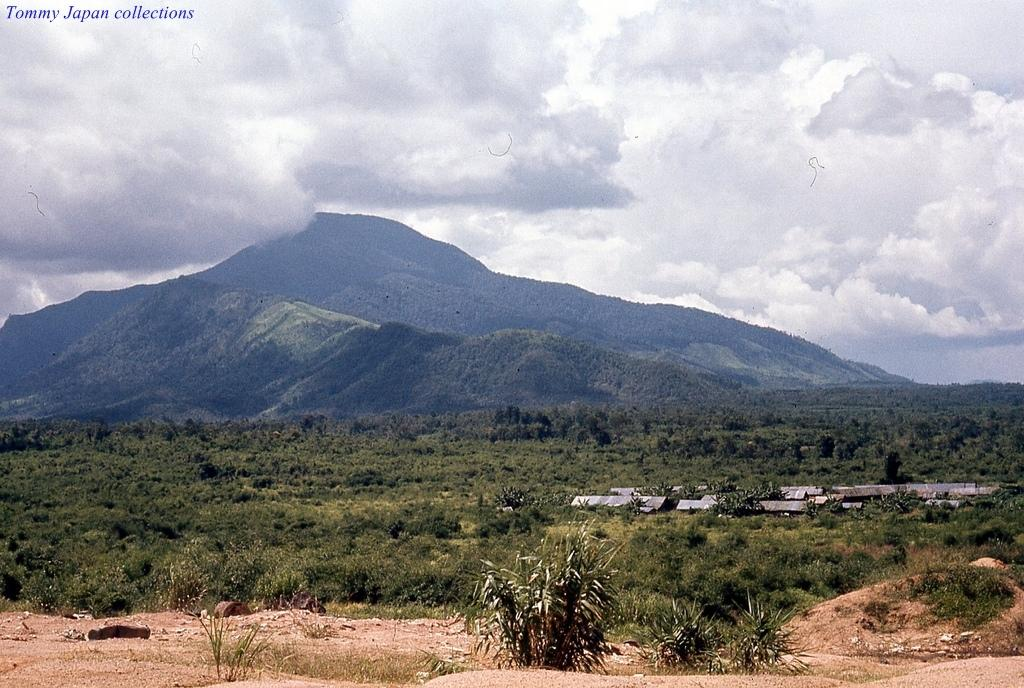What can be found at the bottom of the image? There are plants, trees, pipes, and land at the bottom of the image. What is visible at the top of the image? There are hills, sky, clouds, and text at the top of the image. What type of vegetation is present at the bottom of the image? There are plants and trees at the bottom of the image. What can be seen in the sky at the top of the image? There are clouds in the sky at the top of the image. What type of silk is being used to make the butter in the image? There is no reference to silk or butter in the image. 